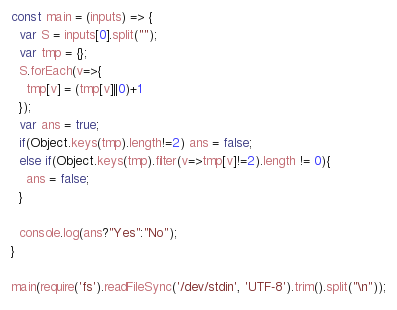<code> <loc_0><loc_0><loc_500><loc_500><_JavaScript_>const main = (inputs) => {
  var S = inputs[0].split("");
  var tmp = {};
  S.forEach(v=>{
    tmp[v] = (tmp[v]||0)+1
  });
  var ans = true;
  if(Object.keys(tmp).length!=2) ans = false;
  else if(Object.keys(tmp).filter(v=>tmp[v]!=2).length != 0){
    ans = false;
  }
  
  console.log(ans?"Yes":"No");
}

main(require('fs').readFileSync('/dev/stdin', 'UTF-8').trim().split("\n"));
</code> 